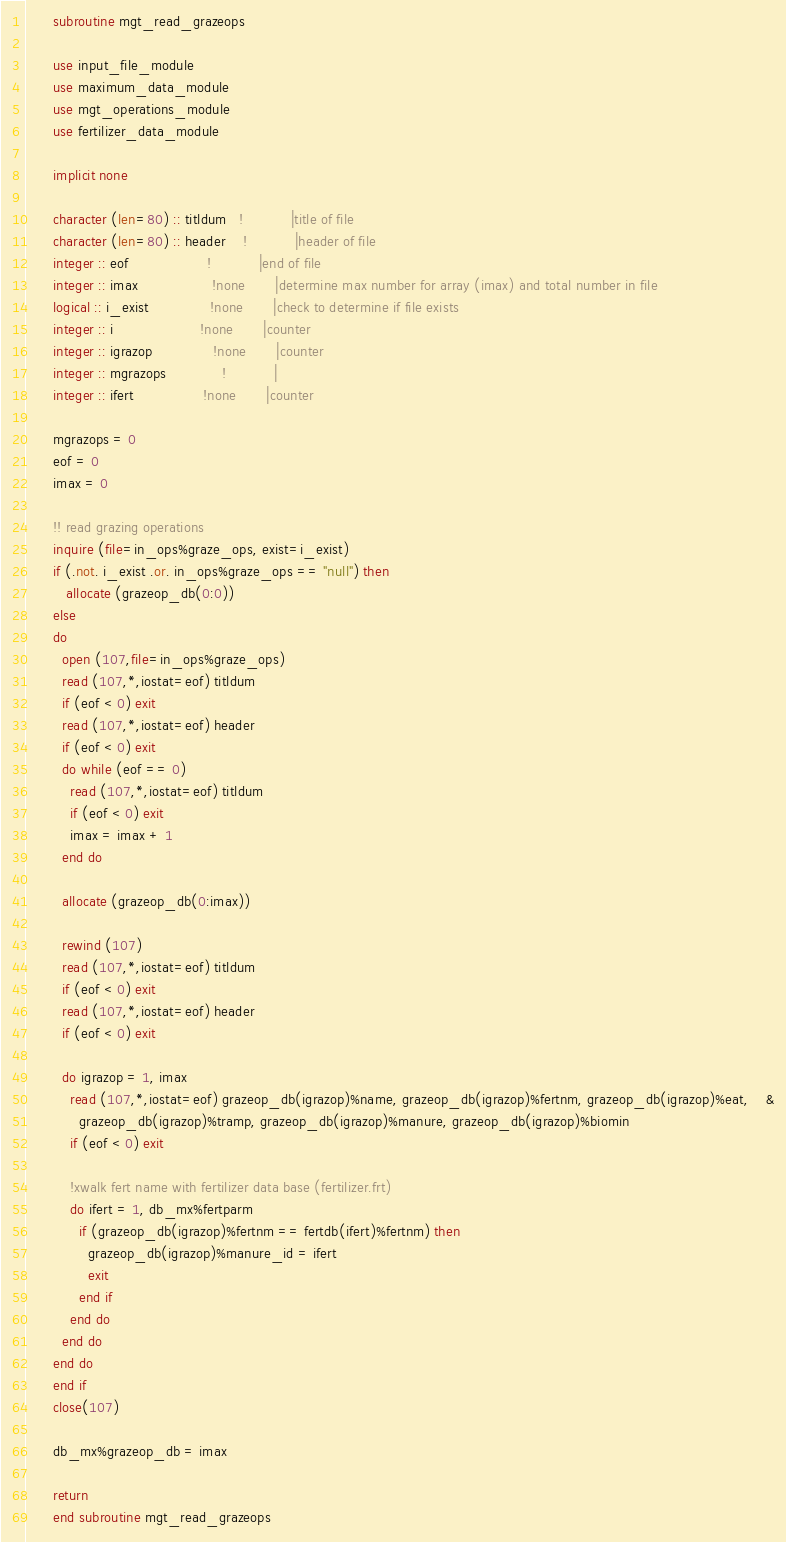Convert code to text. <code><loc_0><loc_0><loc_500><loc_500><_FORTRAN_>      subroutine mgt_read_grazeops
      
      use input_file_module
      use maximum_data_module
      use mgt_operations_module
      use fertilizer_data_module
      
      implicit none       
      
      character (len=80) :: titldum   !           |title of file
      character (len=80) :: header    !           |header of file
      integer :: eof                  !           |end of file
      integer :: imax                 !none       |determine max number for array (imax) and total number in file
      logical :: i_exist              !none       |check to determine if file exists
      integer :: i                    !none       |counter
      integer :: igrazop              !none       |counter
      integer :: mgrazops             !           |
      integer :: ifert                !none       |counter

      mgrazops = 0
      eof = 0
      imax = 0
                                      
      !! read grazing operations
      inquire (file=in_ops%graze_ops, exist=i_exist)
      if (.not. i_exist .or. in_ops%graze_ops == "null") then
         allocate (grazeop_db(0:0))
      else
      do
        open (107,file=in_ops%graze_ops)
        read (107,*,iostat=eof) titldum
        if (eof < 0) exit
        read (107,*,iostat=eof) header
        if (eof < 0) exit
        do while (eof == 0)
          read (107,*,iostat=eof) titldum
          if (eof < 0) exit
          imax = imax + 1
        end do
        
        allocate (grazeop_db(0:imax)) 
        
        rewind (107)
        read (107,*,iostat=eof) titldum
        if (eof < 0) exit
        read (107,*,iostat=eof) header
        if (eof < 0) exit
              
        do igrazop = 1, imax 
          read (107,*,iostat=eof) grazeop_db(igrazop)%name, grazeop_db(igrazop)%fertnm, grazeop_db(igrazop)%eat,    &
            grazeop_db(igrazop)%tramp, grazeop_db(igrazop)%manure, grazeop_db(igrazop)%biomin
          if (eof < 0) exit

          !xwalk fert name with fertilizer data base (fertilizer.frt)
          do ifert = 1, db_mx%fertparm
            if (grazeop_db(igrazop)%fertnm == fertdb(ifert)%fertnm) then
              grazeop_db(igrazop)%manure_id = ifert
              exit
            end if
          end do
        end do
      end do
      end if
      close(107)
 
      db_mx%grazeop_db = imax
      
      return  
      end subroutine mgt_read_grazeops</code> 